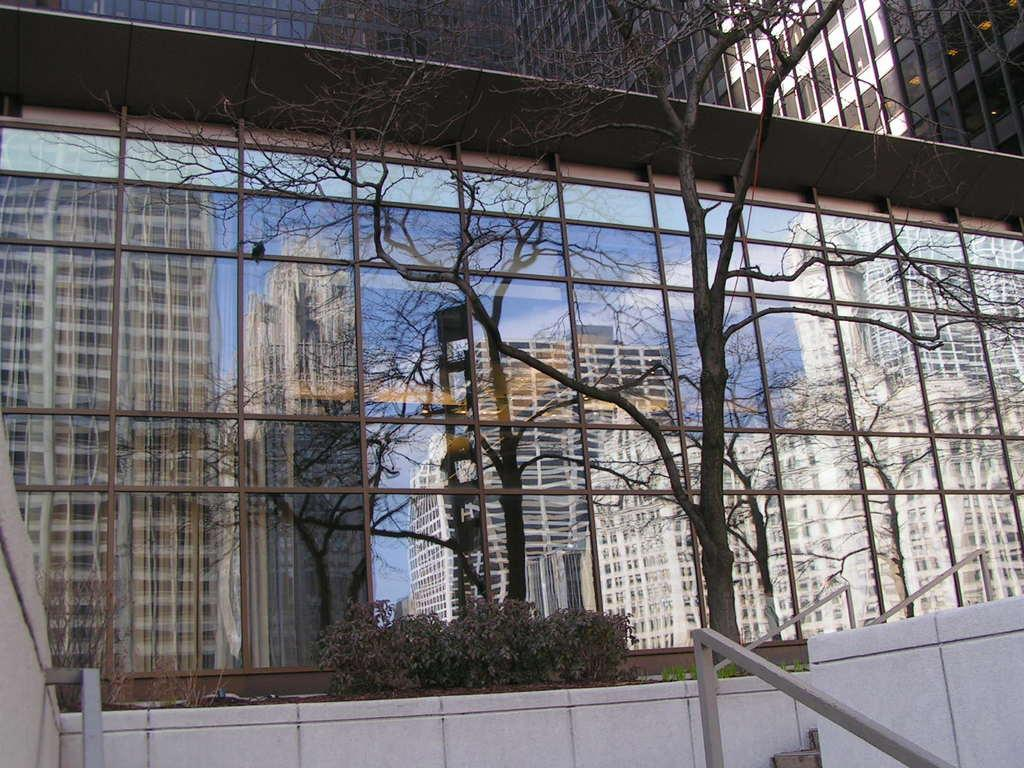What is the main subject in the center of the image? There is a tree in the center of the image. What other types of vegetation can be seen in the image? There are plants in the image. What is the glass in the image reflecting? The glass in the image is reflecting buildings. What can be seen at the top of the image? There are buildings visible at the top of the image. What idea does the man have while standing next to the tree in the image? There is no man present in the image, so it is not possible to determine any ideas he might have. 